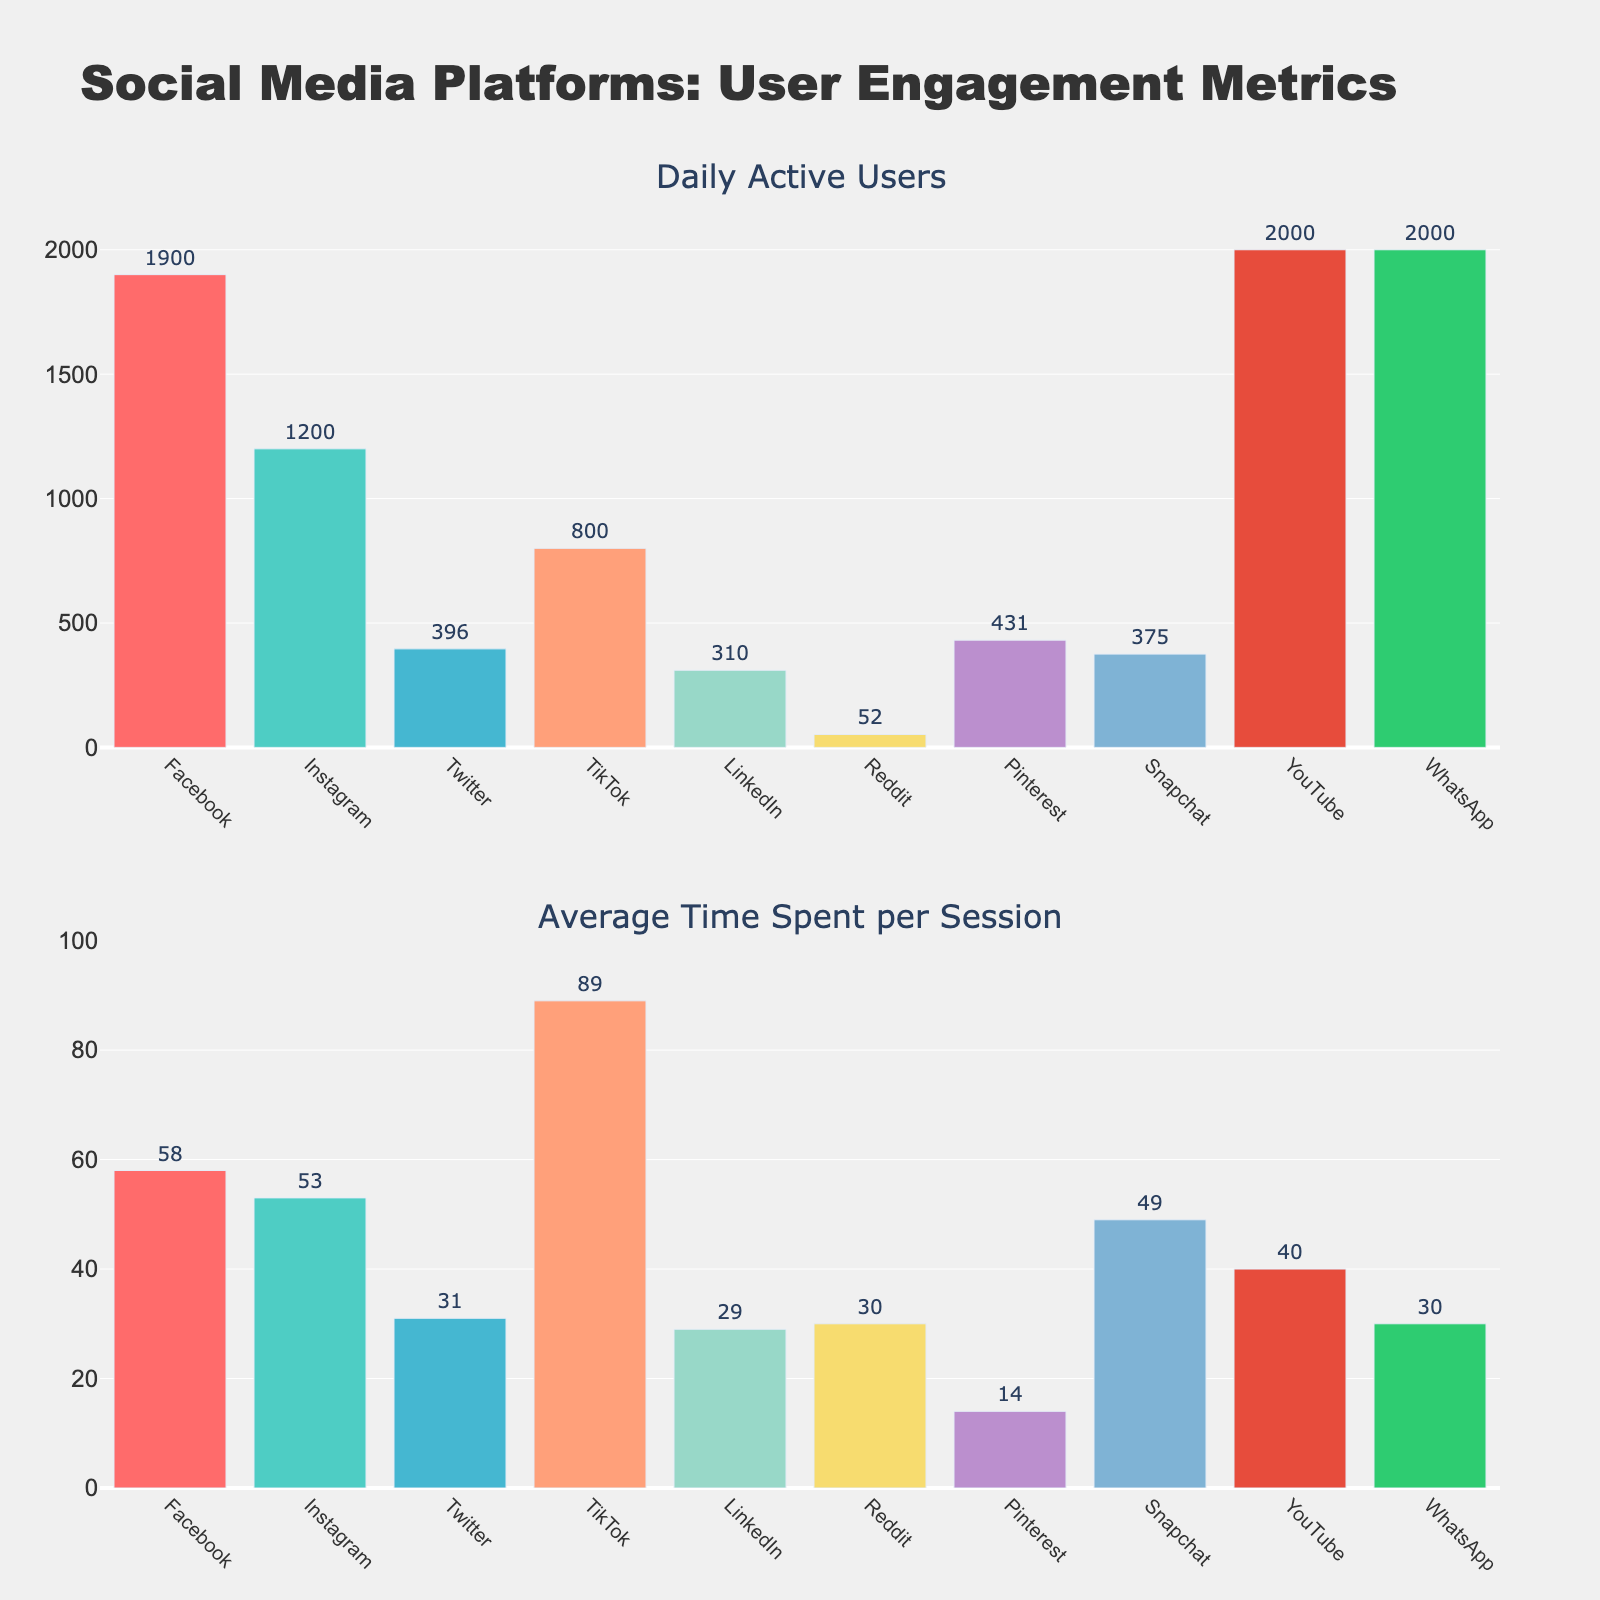what is the title of the figure? The title is usually located at the top of the figure. In this case, the title "Monthly Bird Sightings and Migration Patterns" indicates that the figure shows bird sightings each month along with migration patterns.
Answer: Monthly Bird Sightings and Migration Patterns what months have peak migration periods? Peak migration periods are represented by markers in the second subplot. According to the plot, these markers appear above March, April, May, September, October, and November.
Answer: March, April, May, September, October, November Which month has the highest number of migratory bird sightings? The highest point on the "Migratory Birds" bar in the first subplot indicates the month with the most sightings. In this figure, the tallest bar is in May.
Answer: May What's the total number of common bird sightings in the first half of the year (January to June)? To find the total number, sum the sightings from January to June: 45 (Jan) + 50 (Feb) + 60 (Mar) + 75 (Apr) + 85 (May) + 90 (Jun) = 405.
Answer: 405 Compare the number of common bird sightings to migratory bird sightings in October. Are there more common birds or migratory birds spotted in October? In October, the bar heights show 70 sightings for common birds and 65 sightings for migratory birds. Therefore, there are more common birds than migratory birds.
Answer: Common birds Which months have equal number of common bird sightings? By examining the bar lengths, both February and December have equal common bird sightings, with each having 50 birds.
Answer: February and December What's the average number of migratory bird sightings in the peak migration periods? To calculate the average, sum migratory bird sightings during peak months (March, April, May, September, October, November) and then divide by the number of those months. (35 + 60 + 70 + 55 + 65 + 40) / 6 = 54.17.
Answer: 54.17 What's the difference between the number of common bird sightings and migratory bird sightings in March? Subtract the number of migratory bird sightings (35) from common bird sightings (60) in March: 60 - 35 = 25.
Answer: 25 